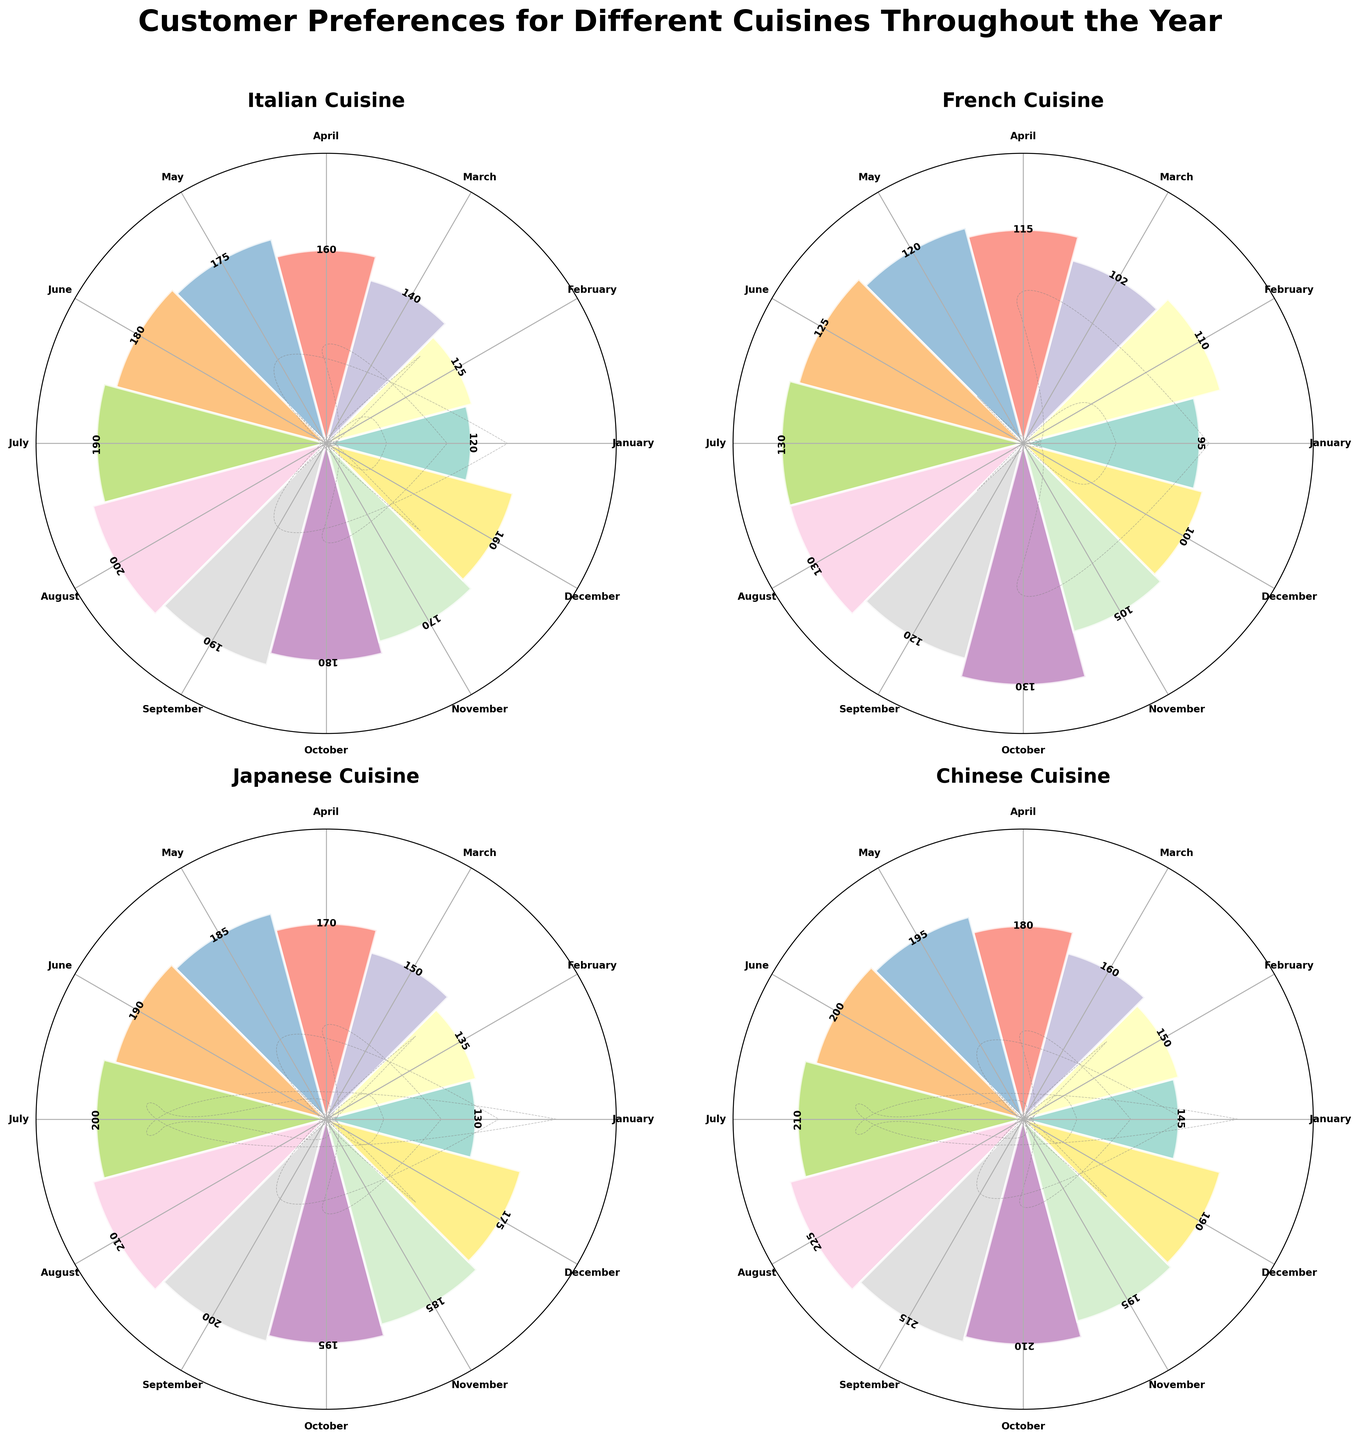How many types of cuisines are displayed in the figure? The figure is a subplot with each subplot representing one cuisine. By counting the number of subplots or titles within subplots, we can determine the number of cuisines displayed.
Answer: 4 What is the overall title of the figure? By examining the figure, we see a large title at the top indicating the subject of the data displayed.
Answer: Customer Preferences for Different Cuisines Throughout the Year Which month has the highest customer count for Japanese cuisine? By looking at the heights of the bars in the Japanese cuisine subplot, identify the month with the tallest bar.
Answer: August Which cuisine had the highest customer count overall in October? By observing each subplot for October and comparing the heights of the bars, identify the cuisine with the highest bar.
Answer: Chinese What is the customer count for Italian cuisine in June? Locate the bar corresponding to June within the Italian cuisine subplot and read the value.
Answer: 180 Which cuisine saw the largest increase in customer count from January to December? For each cuisine, determine the difference between the customer count in December and January. Compare these differences to find the largest increase.
Answer: Japanese (175 - 130 = 45) In which month did French cuisine have the lowest customer count? Identify the month with the shortest bar in the French cuisine subplot.
Answer: January How do the customer preferences for Chinese cuisine in July compare to those in November? Compare the heights of the bars for July and November within the Chinese cuisine subplot. Summarize the comparison.
Answer: Higher in July What is the average customer count for French cuisine across all the months? Sum the customer counts for each month in the French cuisine subplot and divide by the number of months. (95 + 110 + 102 + 115 + 120 + 125 + 130 + 130 + 120 + 130 + 105 + 100) / 12 = 115.42
Answer: 115.42 Did Italian cuisine follow an increasing or decreasing trend in customer count from January to July? Examine the bar heights for Italian cuisine from January to July and observe if the heights generally increase or decrease over time.
Answer: Increasing 